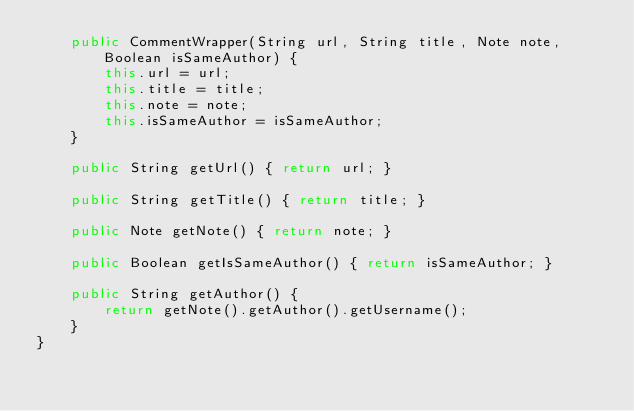Convert code to text. <code><loc_0><loc_0><loc_500><loc_500><_Java_>    public CommentWrapper(String url, String title, Note note, Boolean isSameAuthor) {
        this.url = url;
        this.title = title;
        this.note = note;
        this.isSameAuthor = isSameAuthor;
    }

    public String getUrl() { return url; }

    public String getTitle() { return title; }

    public Note getNote() { return note; }

    public Boolean getIsSameAuthor() { return isSameAuthor; }

    public String getAuthor() {
        return getNote().getAuthor().getUsername();
    }
}
</code> 